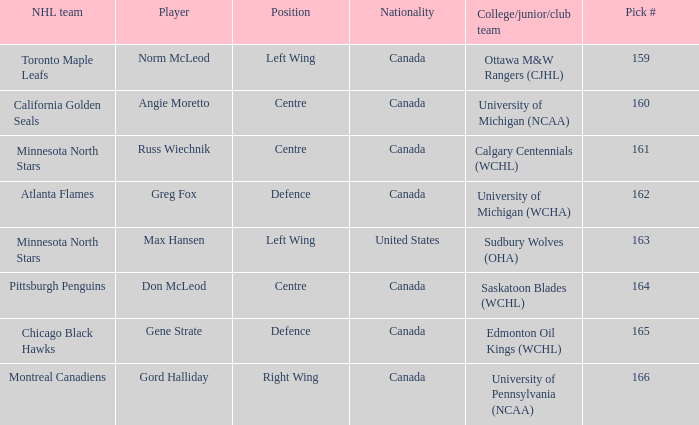What team did Russ Wiechnik, on the centre position, come from? Calgary Centennials (WCHL). 